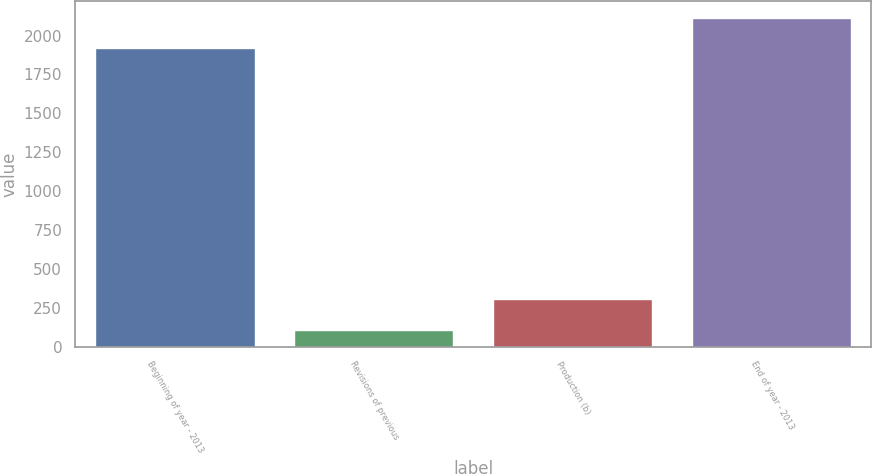<chart> <loc_0><loc_0><loc_500><loc_500><bar_chart><fcel>Beginning of year - 2013<fcel>Revisions of previous<fcel>Production (b)<fcel>End of year - 2013<nl><fcel>1920<fcel>111<fcel>306.4<fcel>2115.4<nl></chart> 